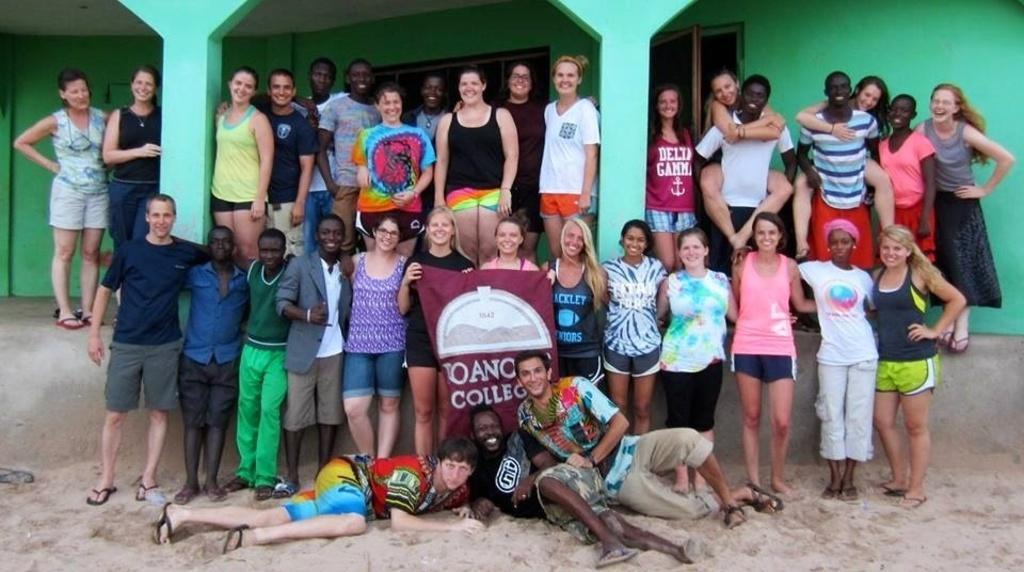In one or two sentences, can you explain what this image depicts? In the center of the image we can see a group of people and some of them are holding cloth. In the background of the image we can see building, windows, wall. At the bottom of the image there is a soil. 